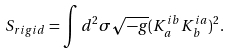<formula> <loc_0><loc_0><loc_500><loc_500>S _ { r i g i d } = \int d ^ { 2 } \sigma \sqrt { - g } ( K _ { a } ^ { i b } K _ { b } ^ { i a } ) ^ { 2 } .</formula> 